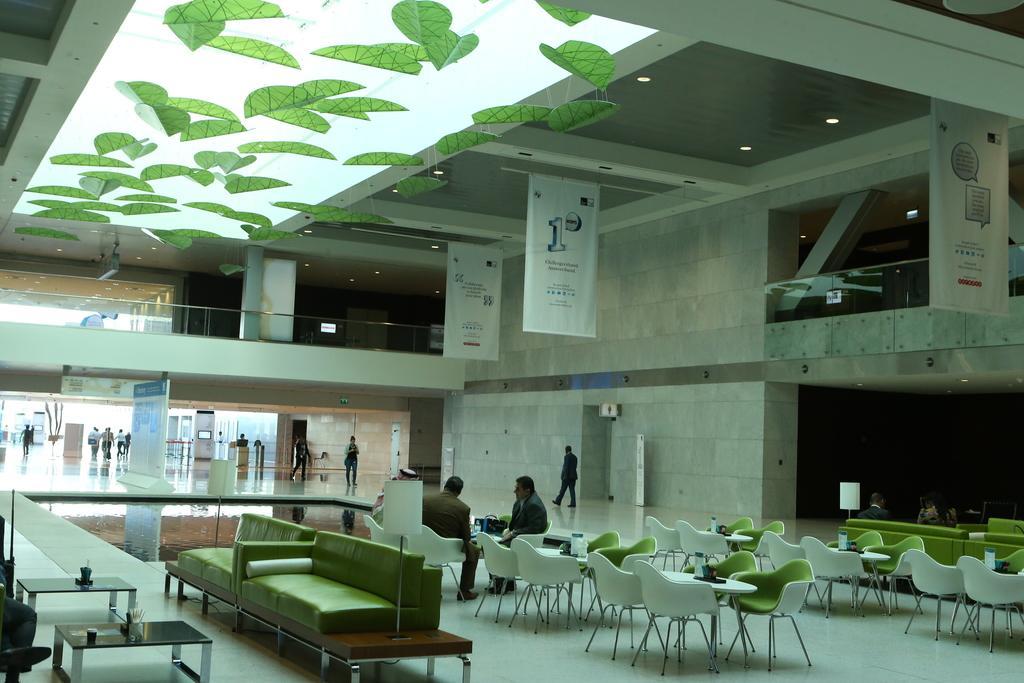Describe this image in one or two sentences. In this picture we can see the inside view of a hall. Here this is the sofa and these are the chairs. There are two tables. And here we can see three persons are sitting on the chairs and some persons are walking on the floor. And this is the wall. These are the banners. 